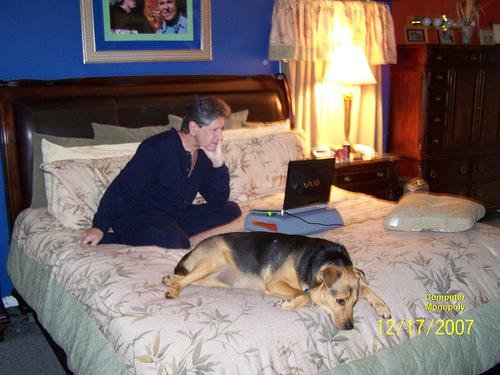Question: where is this scene?
Choices:
A. In a bedroom.
B. The bathroom.
C. In the kitchen.
D. The dinning room.
Answer with the letter. Answer: A Question: what animal is this?
Choices:
A. Cat.
B. Hog.
C. Dog.
D. Wolf.
Answer with the letter. Answer: C Question: who is present?
Choices:
A. Dog.
B. Person.
C. Nobody.
D. Horse.
Answer with the letter. Answer: B Question: why is the dog lain?
Choices:
A. Tired.
B. Doing a trick.
C. Dead.
D. It's being petted.
Answer with the letter. Answer: A Question: how is the photo?
Choices:
A. Blurry.
B. Clear.
C. Underexposed.
D. Out of focus.
Answer with the letter. Answer: B Question: what is the dog in?
Choices:
A. Dirt.
B. Bed.
C. Trouble.
D. Clothes.
Answer with the letter. Answer: B 